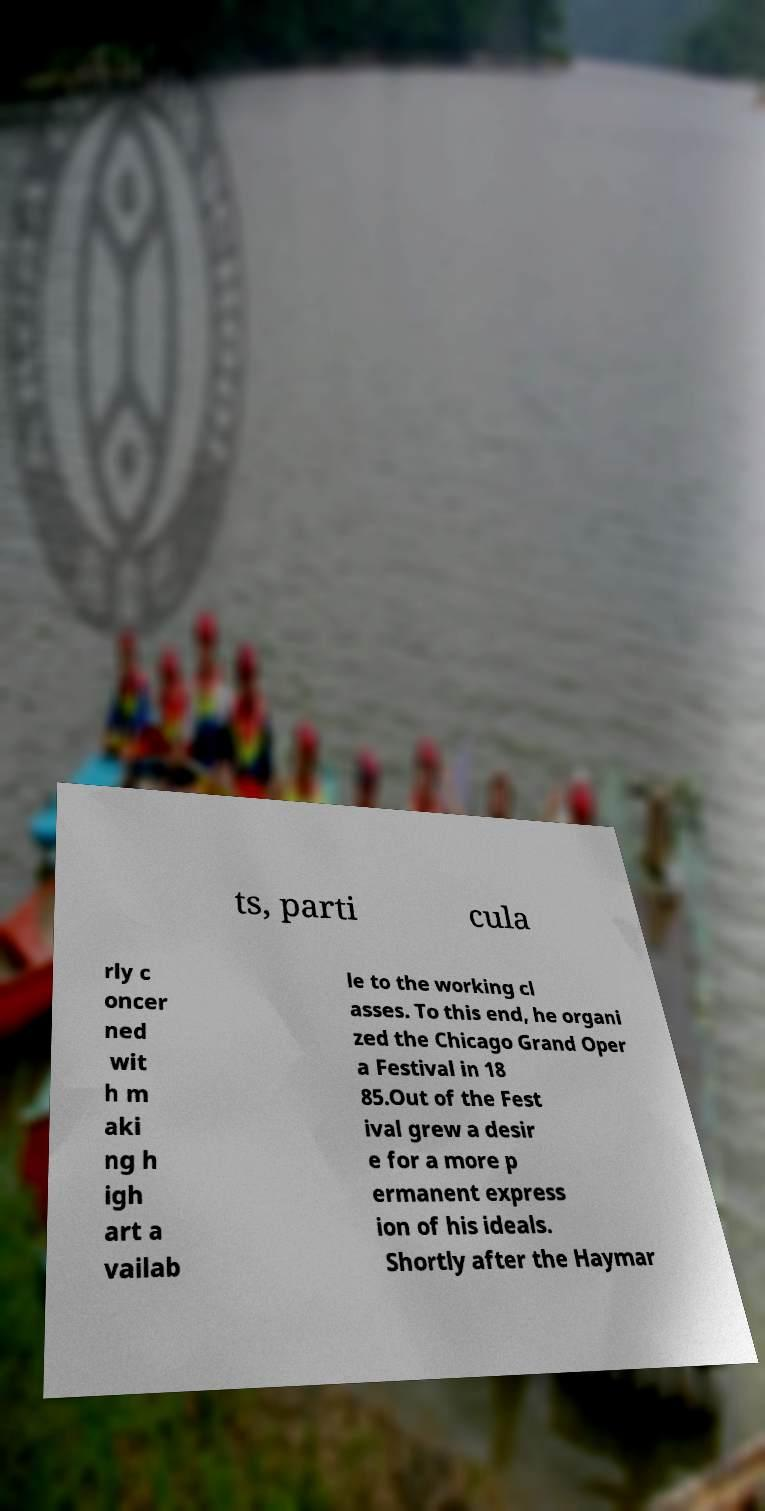I need the written content from this picture converted into text. Can you do that? ts, parti cula rly c oncer ned wit h m aki ng h igh art a vailab le to the working cl asses. To this end, he organi zed the Chicago Grand Oper a Festival in 18 85.Out of the Fest ival grew a desir e for a more p ermanent express ion of his ideals. Shortly after the Haymar 